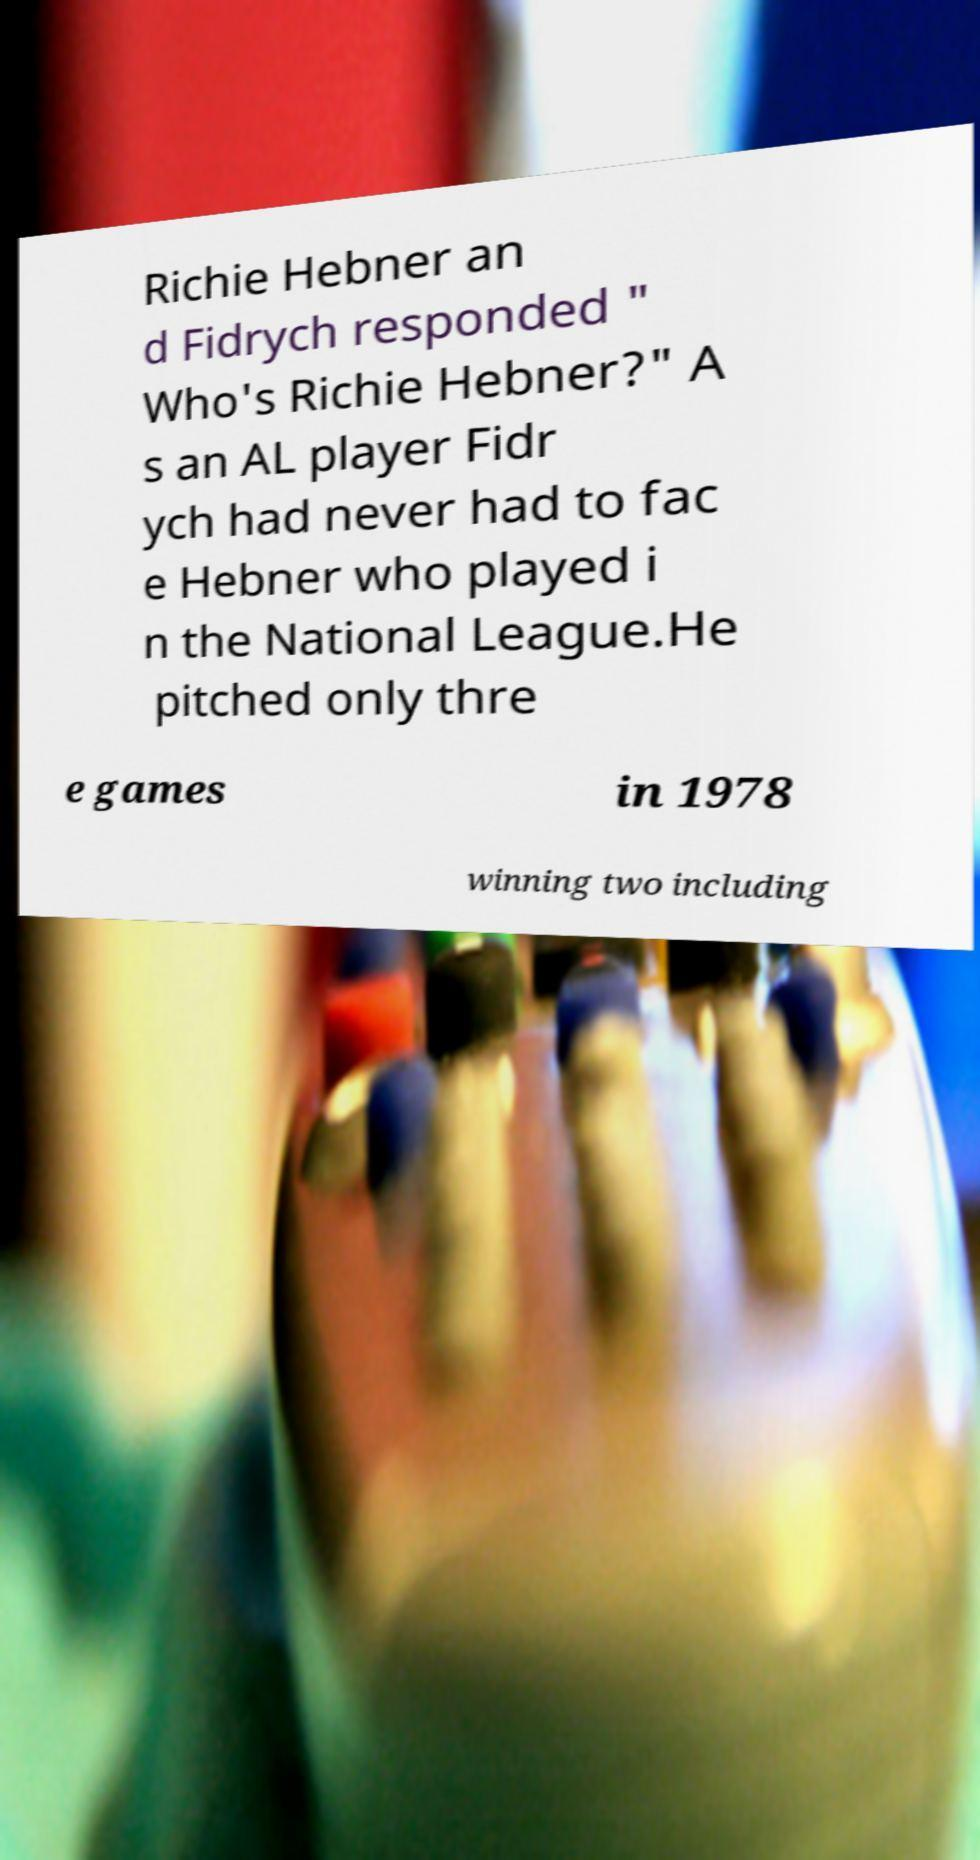Can you read and provide the text displayed in the image?This photo seems to have some interesting text. Can you extract and type it out for me? Richie Hebner an d Fidrych responded " Who's Richie Hebner?" A s an AL player Fidr ych had never had to fac e Hebner who played i n the National League.He pitched only thre e games in 1978 winning two including 